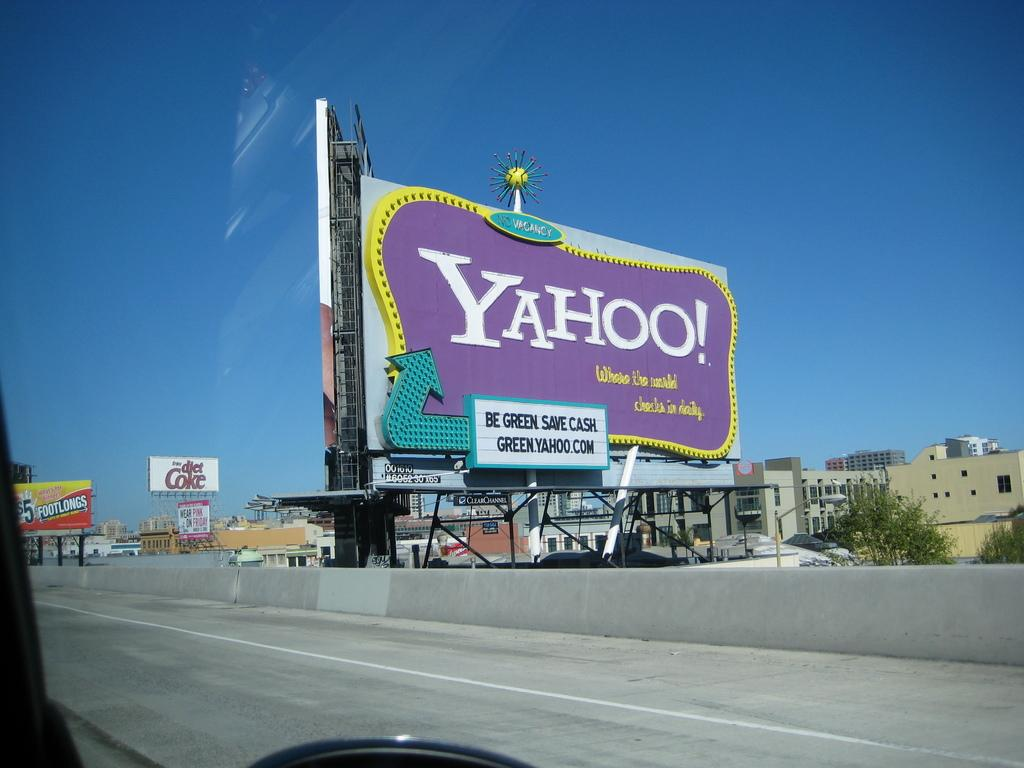<image>
Present a compact description of the photo's key features. A purple and yellow billboard sign advertising Yahoo! 